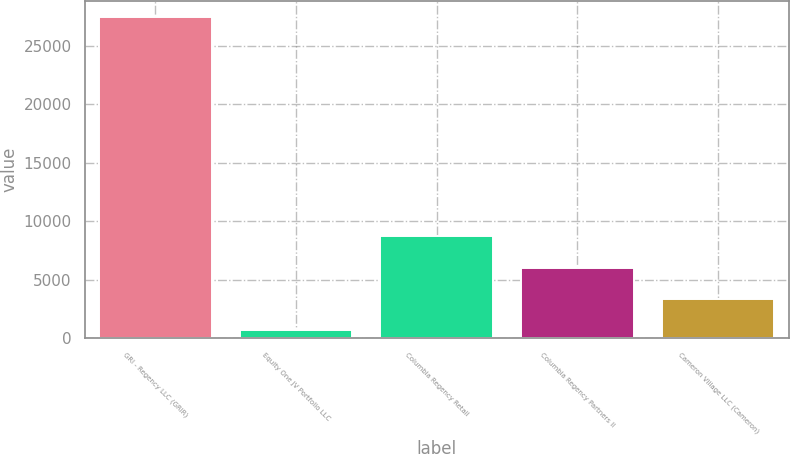Convert chart to OTSL. <chart><loc_0><loc_0><loc_500><loc_500><bar_chart><fcel>GRI - Regency LLC (GRIR)<fcel>Equity One JV Portfolio LLC<fcel>Columbia Regency Retail<fcel>Columbia Regency Partners II<fcel>Cameron Village LLC (Cameron)<nl><fcel>27440<fcel>686<fcel>8712.2<fcel>6036.8<fcel>3361.4<nl></chart> 